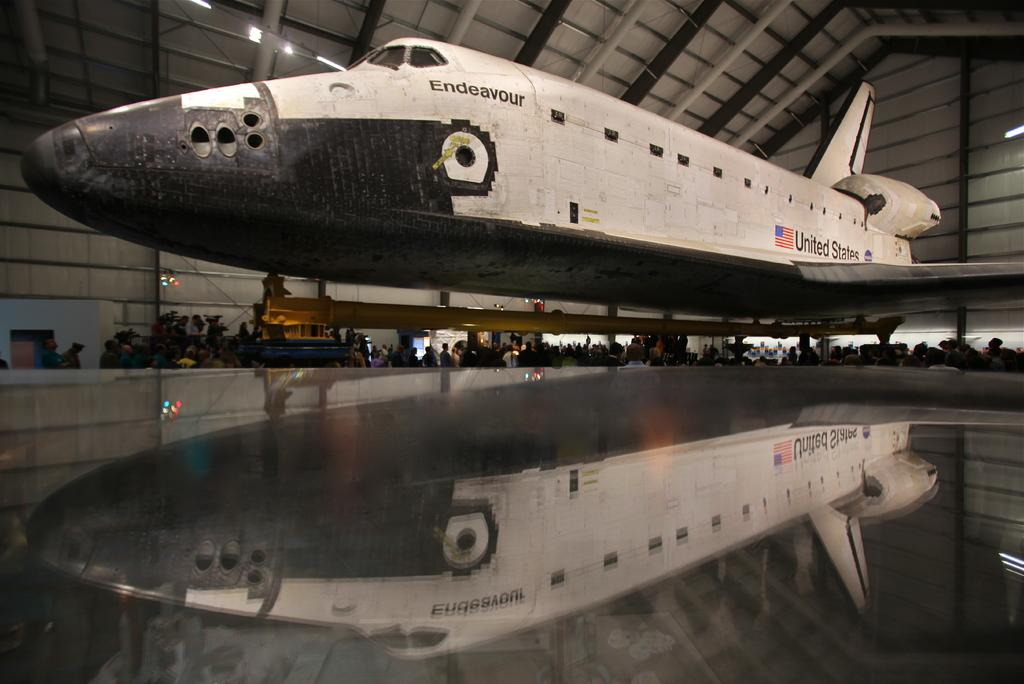What is the color of the aircraft in the image? The aircraft in the image is white-colored. Are there any markings or writings on the aircraft? Yes, there are writings on the aircraft. What can be seen in the background of the image? There are people in the background of the image. Can you describe any additional features of the aircraft in the image? The reflection of the aircraft is visible in the image. Can you see a seashore in the image? No, there is no seashore present in the image. What type of structure is visible near the aircraft in the image? There is no structure visible near the aircraft in the image. 